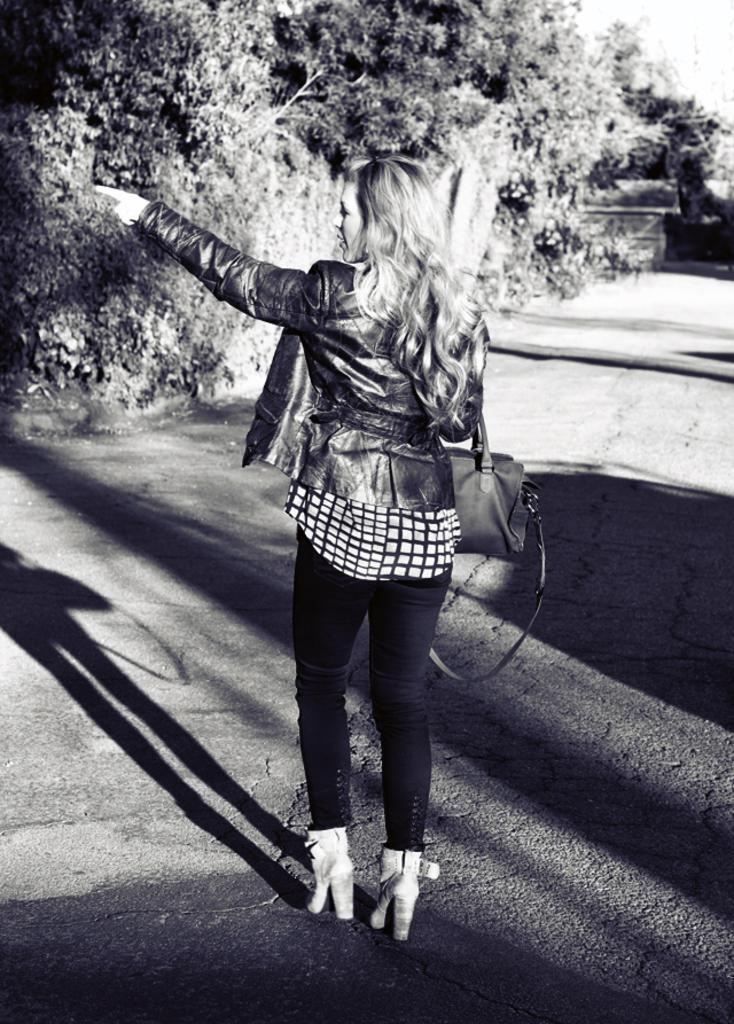Who is present in the image? There is a woman in the image. Where is the woman located? The woman is on the road. What is the woman carrying? The woman is carrying a bag. What can be seen in the background of the image? There are trees and the sky visible in the background of the image. What type of seed is the woman planting in the image? There is no seed or planting activity present in the image. How does the woman's behavior change throughout the image? The image is a still photograph, so the woman's behavior does not change throughout the image. 